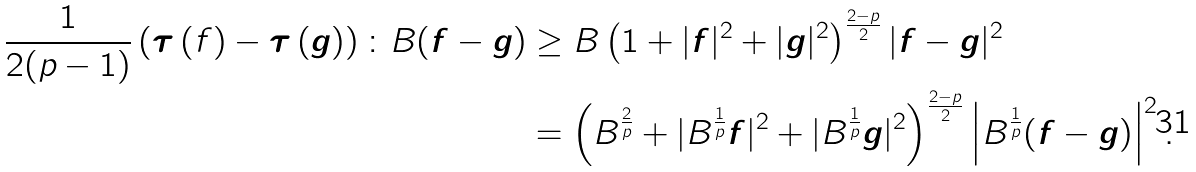<formula> <loc_0><loc_0><loc_500><loc_500>\frac { 1 } { 2 ( p - 1 ) } \left ( { \boldsymbol \tau } \left ( f \right ) - { \boldsymbol \tau } \left ( \boldsymbol g \right ) \right ) \colon B ( \boldsymbol f - \boldsymbol g ) & \geq B \left ( 1 + | \boldsymbol f | ^ { 2 } + | \boldsymbol g | ^ { 2 } \right ) ^ { \frac { 2 - p } { 2 } } | \boldsymbol f - \boldsymbol g | ^ { 2 } \\ & = \left ( B ^ { \frac { 2 } { p } } + | B ^ { \frac { 1 } { p } } \boldsymbol f | ^ { 2 } + | B ^ { \frac { 1 } { p } } \boldsymbol g | ^ { 2 } \right ) ^ { \frac { 2 - p } { 2 } } \left | B ^ { \frac { 1 } { p } } ( \boldsymbol f - \boldsymbol g ) \right | ^ { 2 } .</formula> 